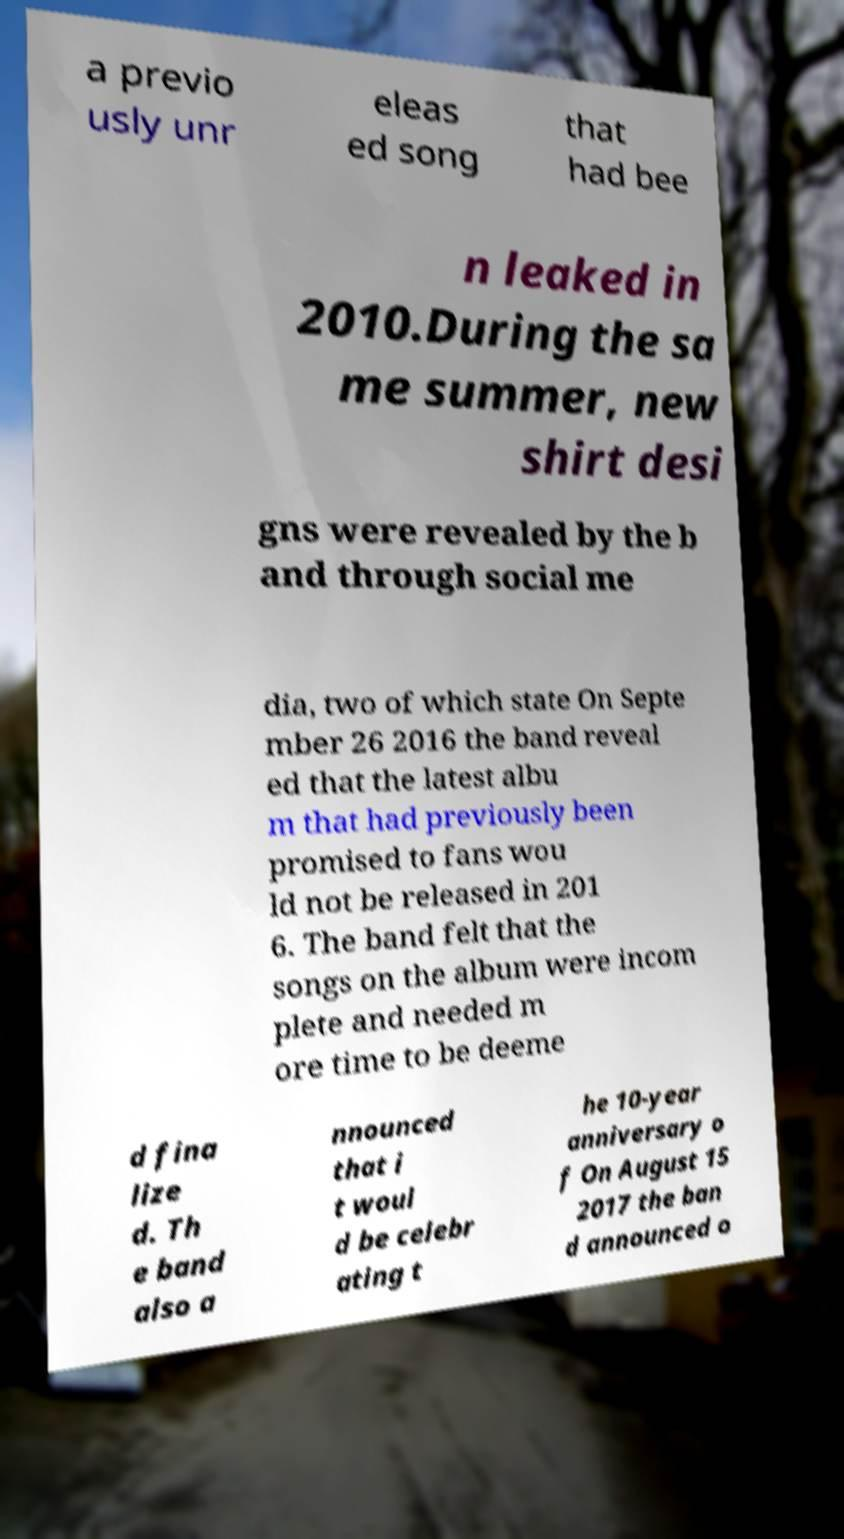What messages or text are displayed in this image? I need them in a readable, typed format. a previo usly unr eleas ed song that had bee n leaked in 2010.During the sa me summer, new shirt desi gns were revealed by the b and through social me dia, two of which state On Septe mber 26 2016 the band reveal ed that the latest albu m that had previously been promised to fans wou ld not be released in 201 6. The band felt that the songs on the album were incom plete and needed m ore time to be deeme d fina lize d. Th e band also a nnounced that i t woul d be celebr ating t he 10-year anniversary o f On August 15 2017 the ban d announced o 